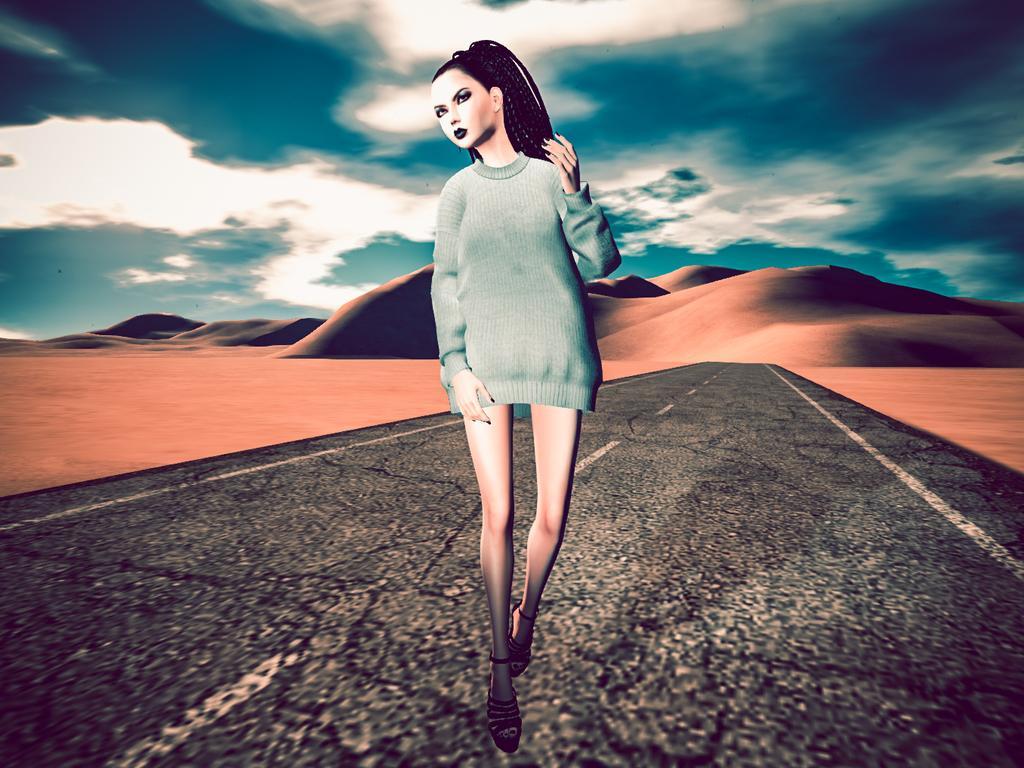How would you summarize this image in a sentence or two? It is an editing picture. In the image in the center, we can see one person standing on the road. In the background we can see the sky, clouds and hills. 